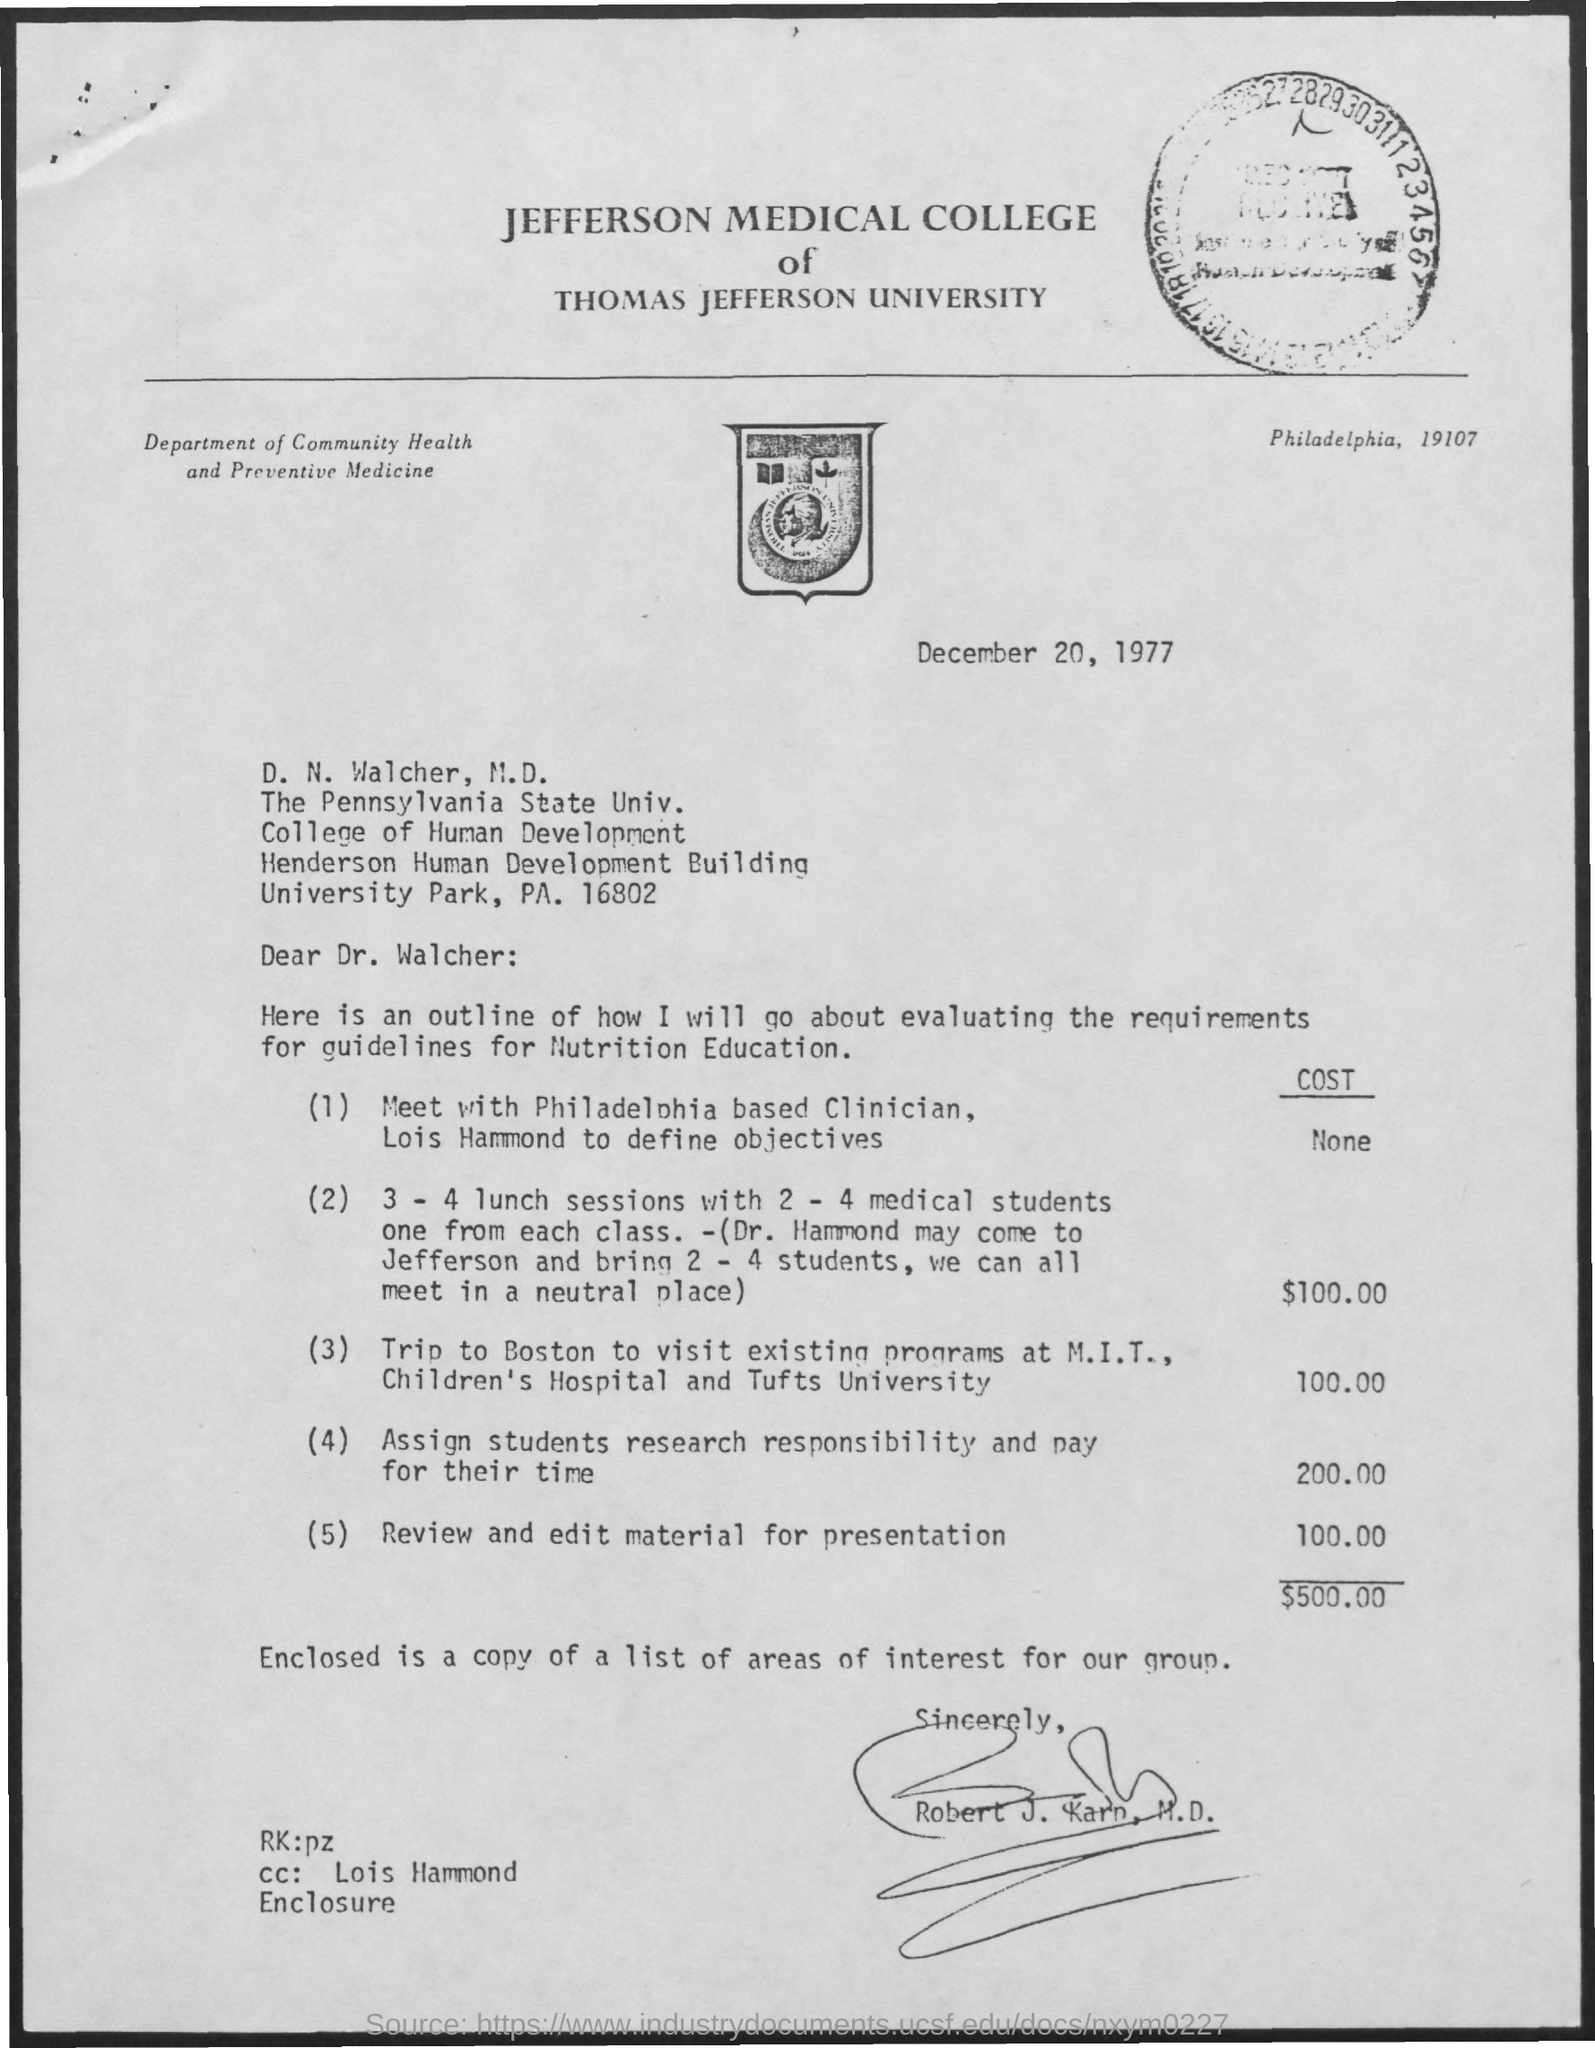Indicate a few pertinent items in this graphic. Jefferson Medical College is a part of Thomas Jefferson University. D. N. Walcher is a student from the College of Human Development. The cost required for reviewing and editing material for presentation is 100.00. The letter has been drafted by Robert J. Karp, M.D. The Department of Community Health and Preventive Medicine is written on the top left side of the letter. 